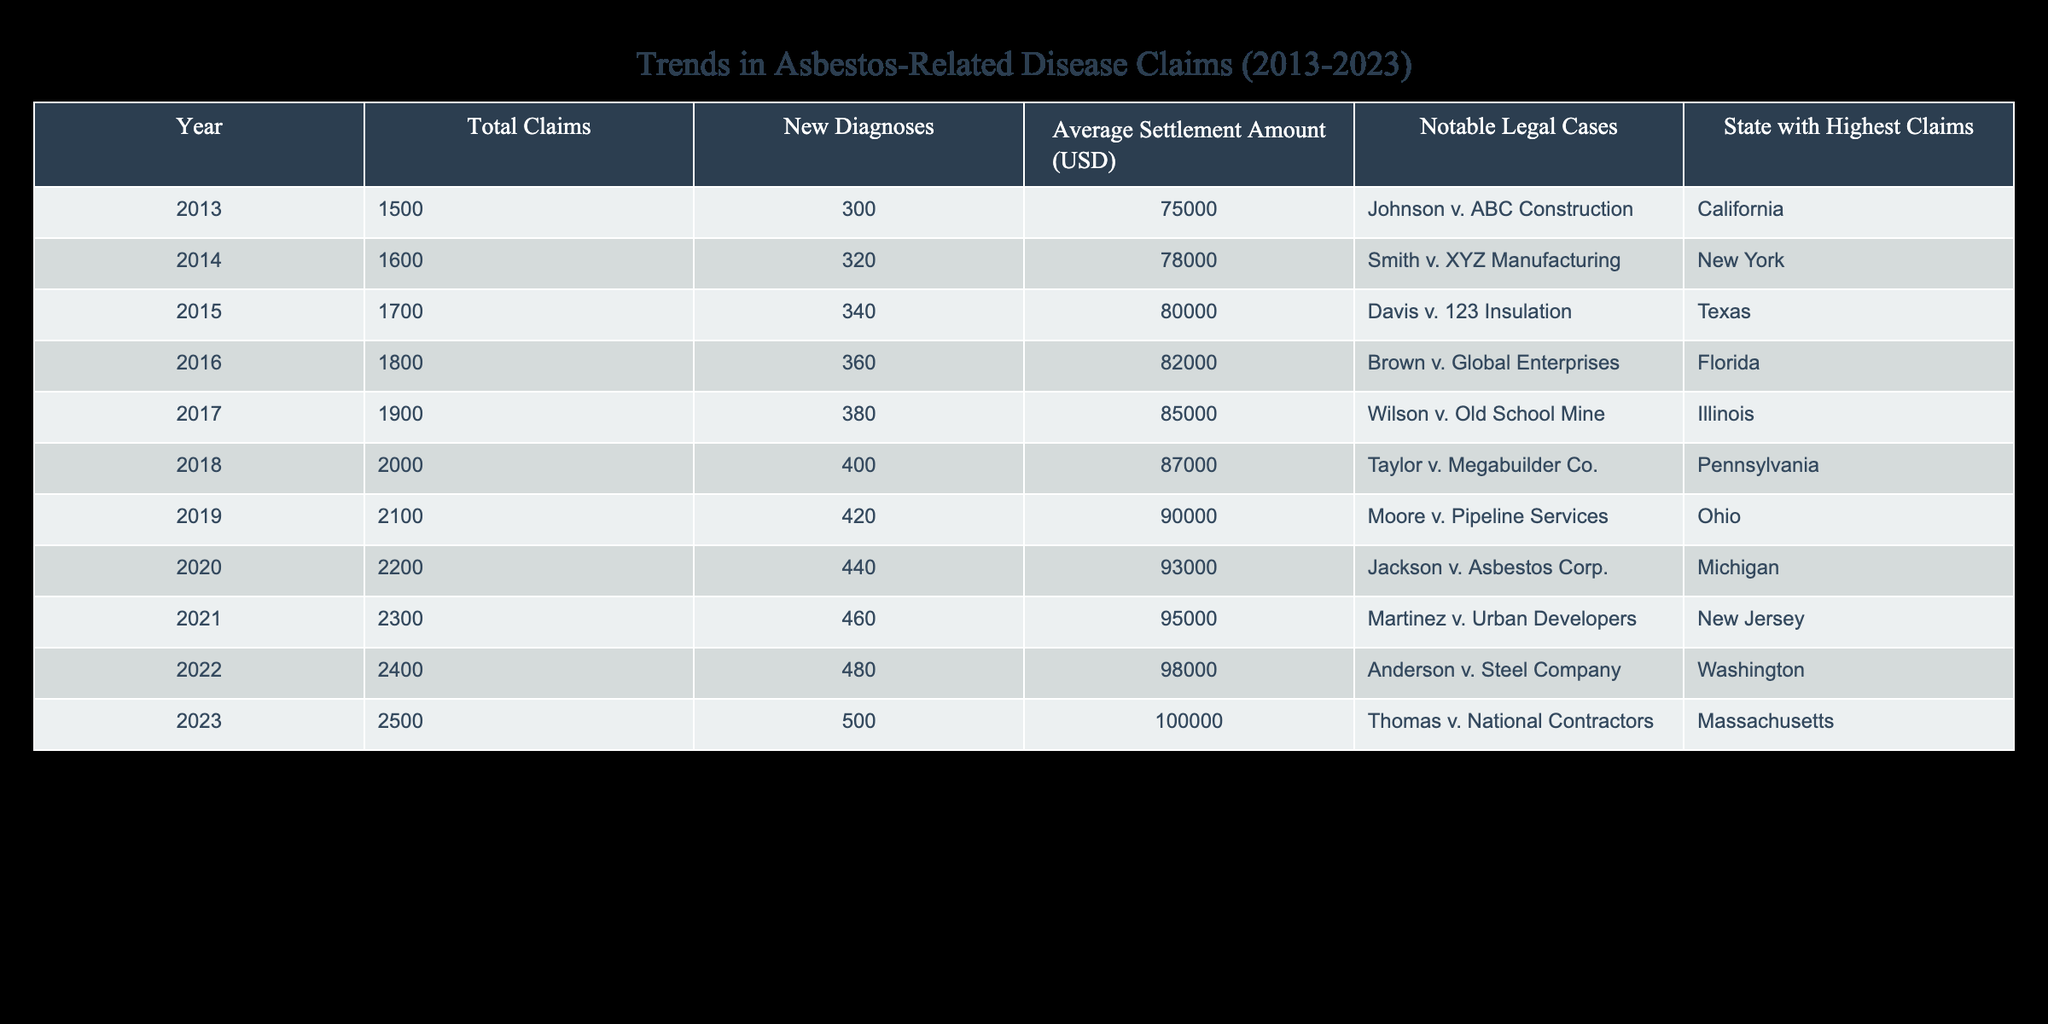What was the total number of asbestos-related claims in 2013? According to the table, the total claims for the year 2013 is explicitly listed as 1500.
Answer: 1500 Which state had the highest number of asbestos-related claims in 2017? The table indicates that in 2017, the state with the highest claims was Illinois.
Answer: Illinois What is the average settlement amount in 2020? From the data, the average settlement amount for the year 2020 is listed as 93000 USD.
Answer: 93000 USD How many total asbestos-related claims were there from 2013 to 2023? To find the total claims for the decade, we sum the claims from each year: 1500 + 1600 + 1700 + 1800 + 1900 + 2000 + 2100 + 2200 + 2300 + 2400 + 2500 =  16500.
Answer: 16500 Was there an increase in the average settlement amount from 2019 to 2023? The average settlement amount in 2019 was 90000 USD and in 2023 it was 100000 USD. Since 100000 is greater than 90000, there was definitely an increase.
Answer: Yes What is the difference in new diagnoses between 2014 and 2021? The number of new diagnoses in 2014 was 320 and in 2021 it was 460. To find the difference, subtract 320 from 460; 460 - 320 = 140.
Answer: 140 Which notable legal case had the highest average settlement amount in the last decade? Looking at the table, we can see that the average settlement amount increased each year, reaching a peak of 100000 USD in 2023. Therefore, the notable legal case in that year, Thomas v. National Contractors, is associated with the highest settlement amount.
Answer: Thomas v. National Contractors How many new asbestos diagnoses were made in 2015 compared to 2023? In 2015, there were 340 new diagnoses, while in 2023 there were 500. To compare, we subtract: 500 - 340 = 160.
Answer: 160 Was the total number of asbestos-related claims higher in 2018 than in 2015? The table shows that total claims in 2018 were 2000 and in 2015 were 1700. Since 2000 is greater than 1700, the claim count in 2018 was indeed higher.
Answer: Yes 